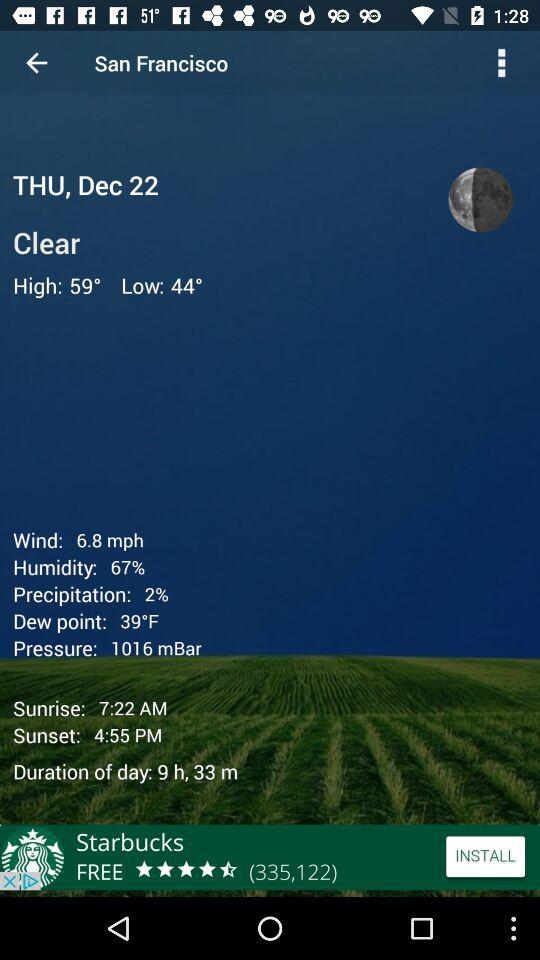What is the wind speed in San Francisco? The wind speed is 6.8 mph. 